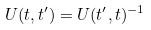Convert formula to latex. <formula><loc_0><loc_0><loc_500><loc_500>U ( t , t ^ { \prime } ) = U ( t ^ { \prime } , t ) ^ { - 1 }</formula> 